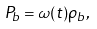Convert formula to latex. <formula><loc_0><loc_0><loc_500><loc_500>P _ { b } = \omega ( t ) \rho _ { b } ,</formula> 